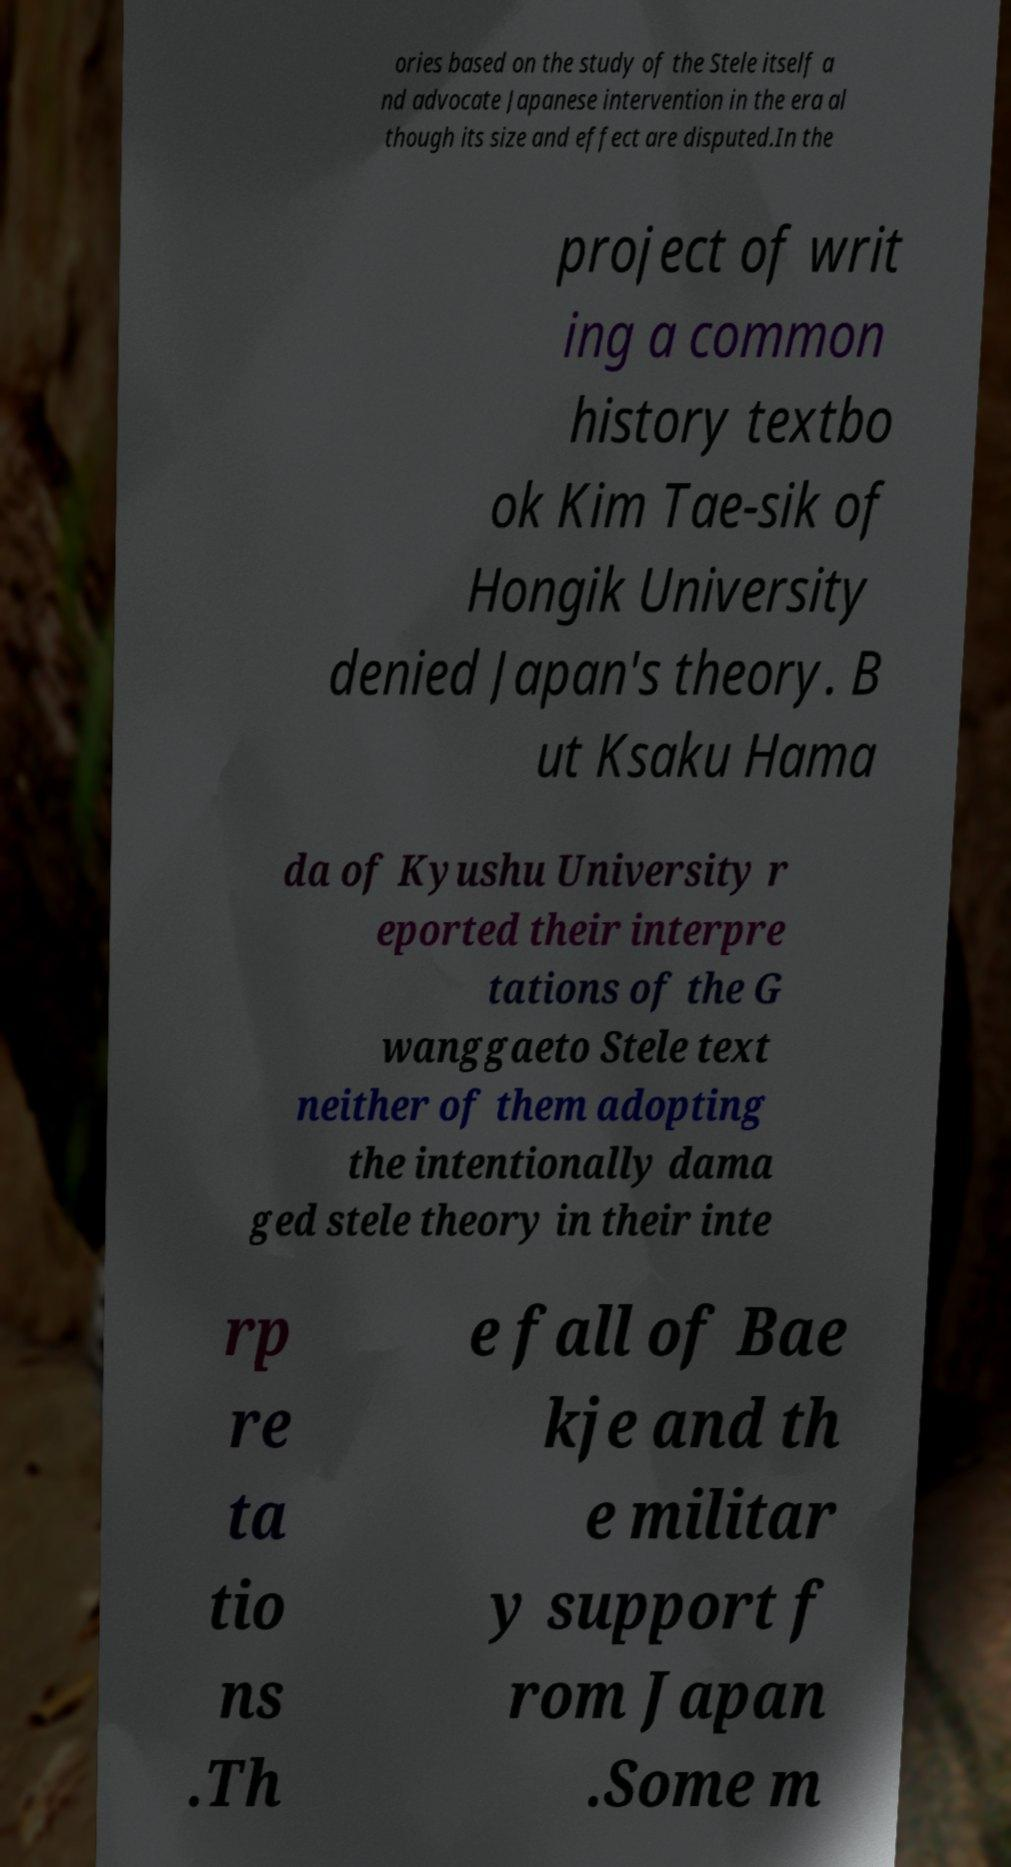Can you read and provide the text displayed in the image?This photo seems to have some interesting text. Can you extract and type it out for me? ories based on the study of the Stele itself a nd advocate Japanese intervention in the era al though its size and effect are disputed.In the project of writ ing a common history textbo ok Kim Tae-sik of Hongik University denied Japan's theory. B ut Ksaku Hama da of Kyushu University r eported their interpre tations of the G wanggaeto Stele text neither of them adopting the intentionally dama ged stele theory in their inte rp re ta tio ns .Th e fall of Bae kje and th e militar y support f rom Japan .Some m 